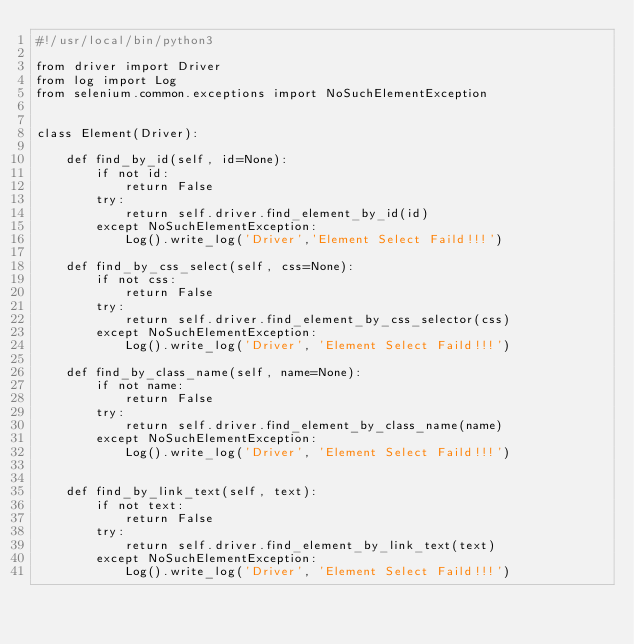Convert code to text. <code><loc_0><loc_0><loc_500><loc_500><_Python_>#!/usr/local/bin/python3

from driver import Driver
from log import Log
from selenium.common.exceptions import NoSuchElementException


class Element(Driver):

    def find_by_id(self, id=None):
        if not id:
            return False
        try:
            return self.driver.find_element_by_id(id)
        except NoSuchElementException:
            Log().write_log('Driver','Element Select Faild!!!')

    def find_by_css_select(self, css=None):
        if not css:
            return False
        try:
            return self.driver.find_element_by_css_selector(css)
        except NoSuchElementException:
            Log().write_log('Driver', 'Element Select Faild!!!')

    def find_by_class_name(self, name=None):
        if not name:
            return False
        try:
            return self.driver.find_element_by_class_name(name)
        except NoSuchElementException:
            Log().write_log('Driver', 'Element Select Faild!!!')


    def find_by_link_text(self, text):
        if not text:
            return False
        try:
            return self.driver.find_element_by_link_text(text)
        except NoSuchElementException:
            Log().write_log('Driver', 'Element Select Faild!!!')
</code> 